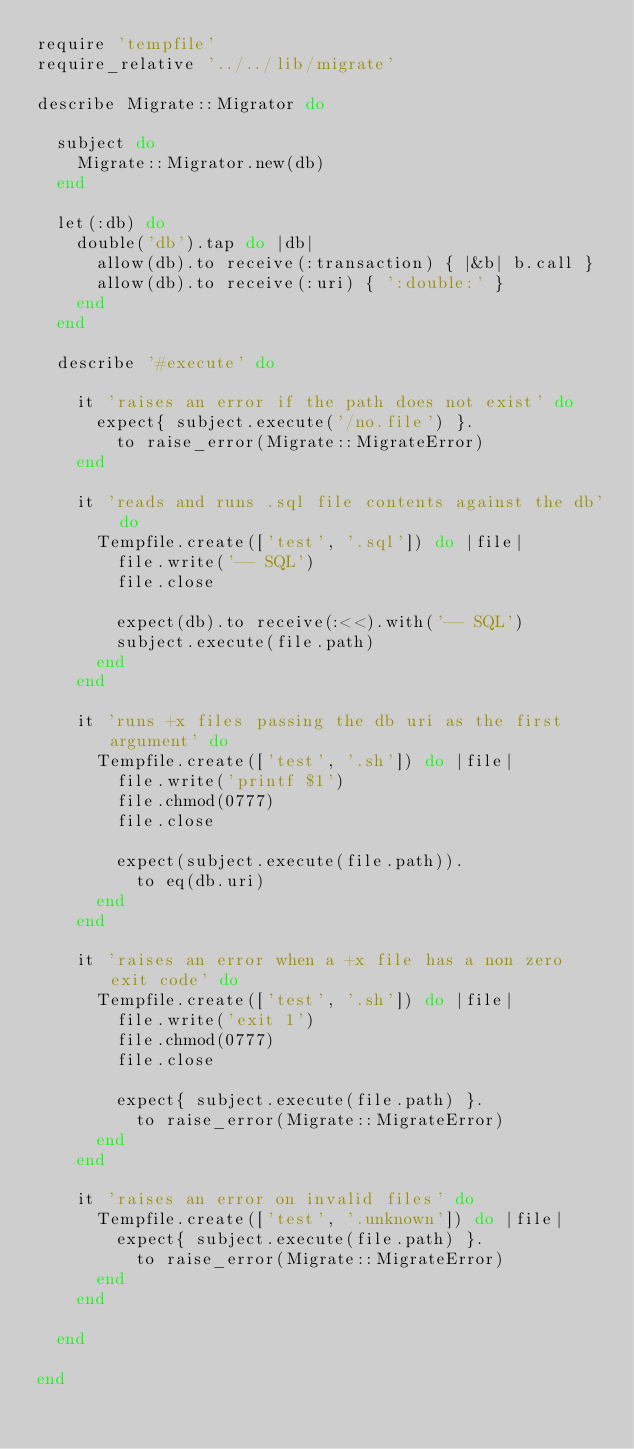Convert code to text. <code><loc_0><loc_0><loc_500><loc_500><_Ruby_>require 'tempfile'
require_relative '../../lib/migrate'

describe Migrate::Migrator do

  subject do
    Migrate::Migrator.new(db)
  end

  let(:db) do
    double('db').tap do |db|
      allow(db).to receive(:transaction) { |&b| b.call }
      allow(db).to receive(:uri) { ':double:' }
    end
  end

  describe '#execute' do

    it 'raises an error if the path does not exist' do
      expect{ subject.execute('/no.file') }.
        to raise_error(Migrate::MigrateError)
    end

    it 'reads and runs .sql file contents against the db' do
      Tempfile.create(['test', '.sql']) do |file|
        file.write('-- SQL')
        file.close

        expect(db).to receive(:<<).with('-- SQL')
        subject.execute(file.path)
      end
    end

    it 'runs +x files passing the db uri as the first argument' do
      Tempfile.create(['test', '.sh']) do |file|
        file.write('printf $1')
        file.chmod(0777)
        file.close

        expect(subject.execute(file.path)).
          to eq(db.uri)
      end
    end

    it 'raises an error when a +x file has a non zero exit code' do
      Tempfile.create(['test', '.sh']) do |file|
        file.write('exit 1')
        file.chmod(0777)
        file.close

        expect{ subject.execute(file.path) }.
          to raise_error(Migrate::MigrateError)
      end
    end

    it 'raises an error on invalid files' do
      Tempfile.create(['test', '.unknown']) do |file|
        expect{ subject.execute(file.path) }.
          to raise_error(Migrate::MigrateError)
      end
    end

  end

end

</code> 